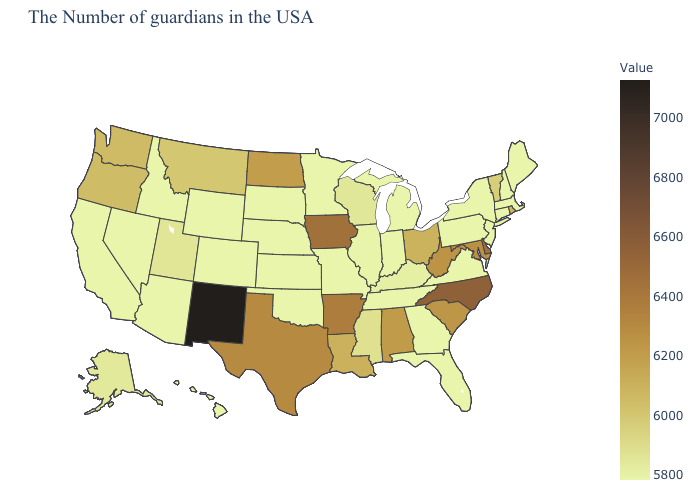Among the states that border Utah , which have the lowest value?
Quick response, please. Wyoming, Colorado, Arizona, Idaho, Nevada. Which states have the lowest value in the Northeast?
Be succinct. Maine, Massachusetts, New Hampshire, Connecticut, New York, New Jersey, Pennsylvania. Does Kansas have the lowest value in the MidWest?
Give a very brief answer. Yes. Does Michigan have the lowest value in the USA?
Keep it brief. Yes. Which states have the lowest value in the West?
Short answer required. Wyoming, Colorado, Arizona, Idaho, Nevada, California, Hawaii. Which states hav the highest value in the West?
Be succinct. New Mexico. Among the states that border Minnesota , does Iowa have the lowest value?
Short answer required. No. 